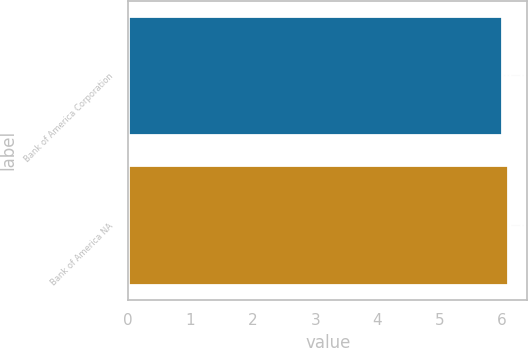<chart> <loc_0><loc_0><loc_500><loc_500><bar_chart><fcel>Bank of America Corporation<fcel>Bank of America NA<nl><fcel>6<fcel>6.1<nl></chart> 